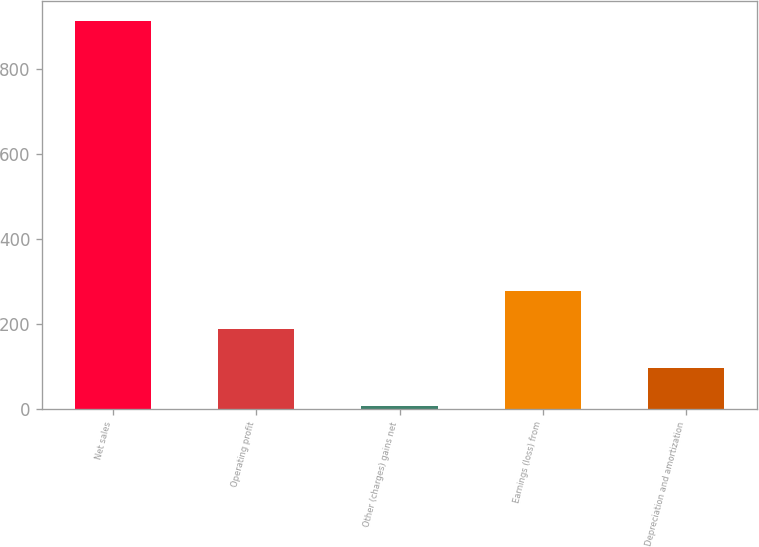<chart> <loc_0><loc_0><loc_500><loc_500><bar_chart><fcel>Net sales<fcel>Operating profit<fcel>Other (charges) gains net<fcel>Earnings (loss) from<fcel>Depreciation and amortization<nl><fcel>915<fcel>187.8<fcel>6<fcel>278.7<fcel>96.9<nl></chart> 